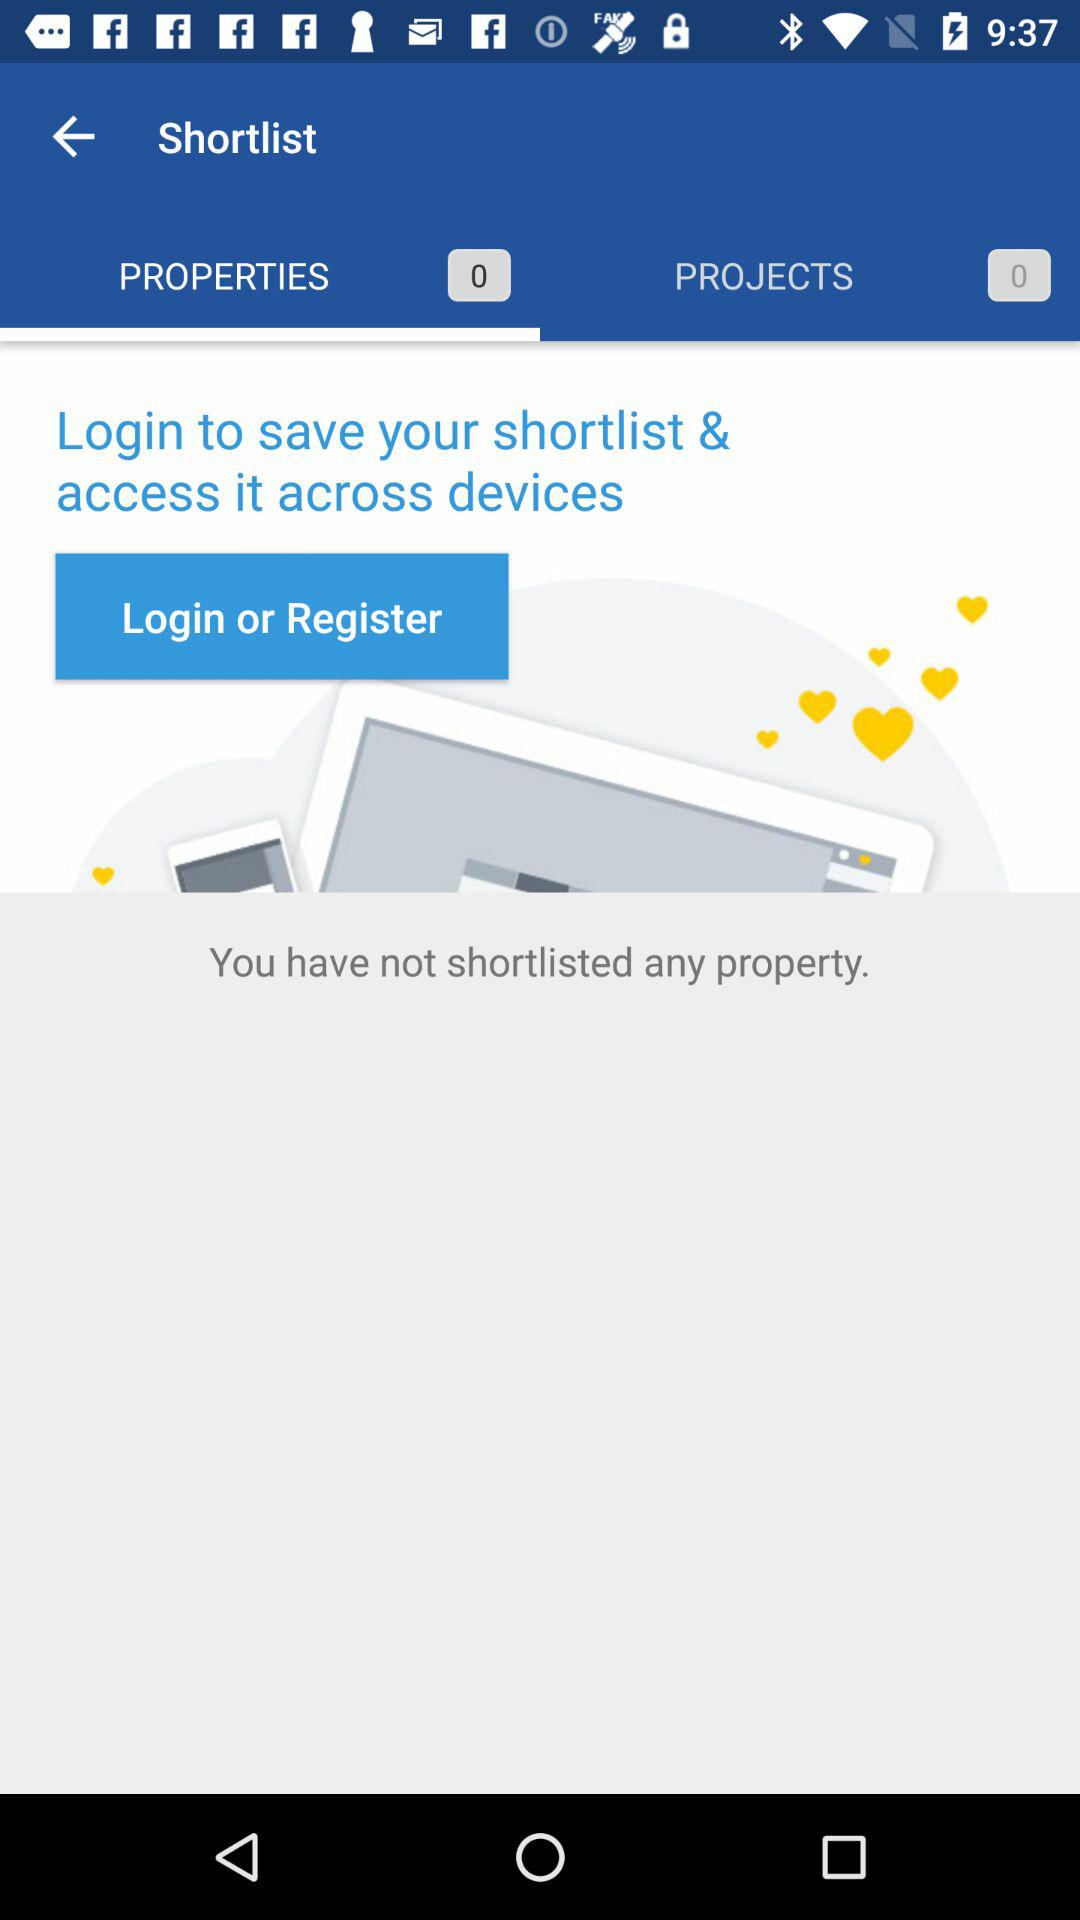What is the number of projects shortlisted? The number of projects shortlisted is 0. 